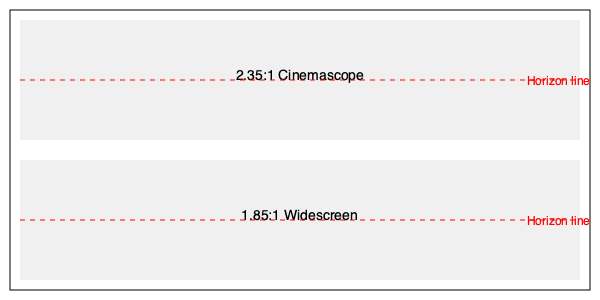In the context of the given frame comparisons, explain how the choice between 2.35:1 Cinemascope and 1.85:1 Widescreen aspect ratios impacts the visual storytelling, particularly in relation to the placement of the horizon line. How might this affect the audience's perception and the overall cinematic experience? To answer this question, we need to consider several factors:

1. Aspect Ratio Basics:
   - 2.35:1 Cinemascope is wider and more expansive.
   - 1.85:1 Widescreen is closer to the standard 16:9 TV aspect ratio.

2. Horizon Line Placement:
   - In both frames, the horizon line is placed at the vertical center.
   - The 2.35:1 ratio provides more horizontal space above and below the horizon.

3. Visual Storytelling Impact:
   a) Cinemascope (2.35:1):
      - Offers a more panoramic view, emphasizing the landscape.
      - Can create a sense of isolation for characters by showing more empty space.
      - Allows for more complex horizontal compositions.

   b) Widescreen (1.85:1):
      - Provides a more balanced frame, closer to human peripheral vision.
      - Gives more vertical space for character framing.
      - Can create a more intimate feel, focusing on characters over environment.

4. Audience Perception:
   - Cinemascope may immerse viewers more in expansive environments.
   - Widescreen might draw more attention to character interactions and facial expressions.

5. Cinematic Experience:
   - Cinemascope is often associated with epic, grandiose storytelling.
   - Widescreen can feel more naturalistic and less stylized.

6. Directorial Choice:
   - The choice between these ratios can significantly impact the visual language of the film.
   - It affects shot composition, camera movement, and overall visual strategy.

The director must consider how these aspects align with the story's themes, genre, and intended emotional impact on the audience.
Answer: Cinemascope emphasizes landscapes and isolation, while Widescreen focuses on characters and intimacy, each shaping the audience's perception and cinematic experience differently. 